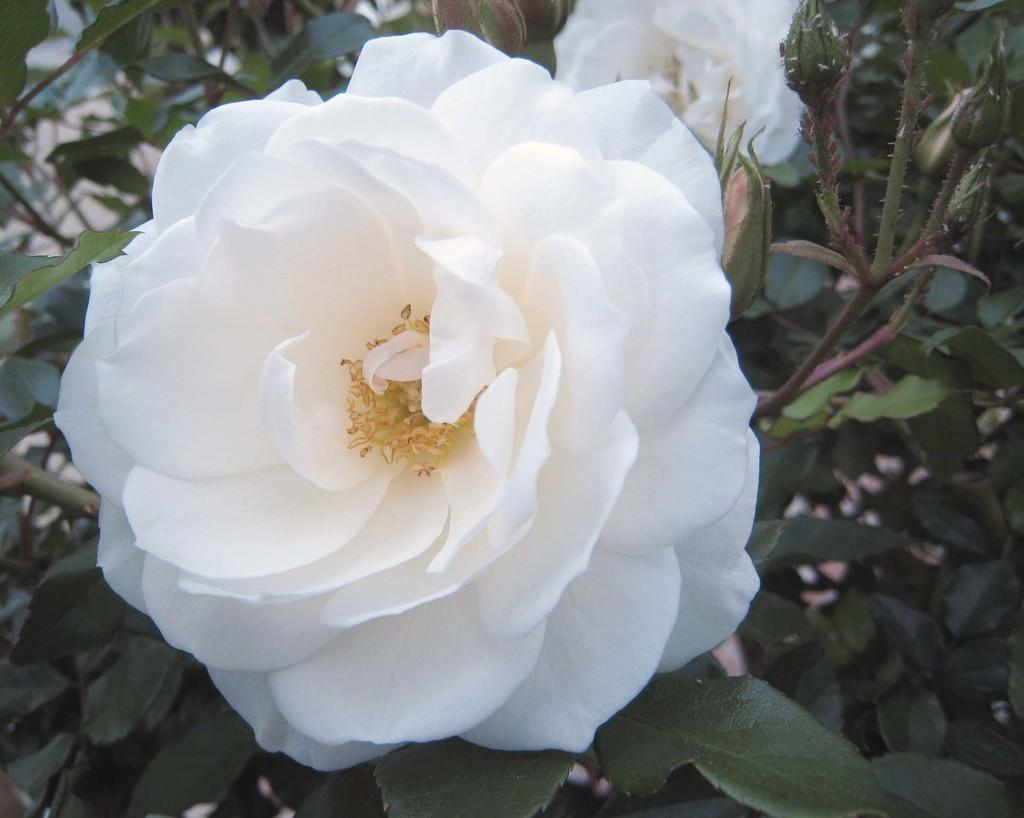What type of vegetation is in the front of the image? There are flowers in the front of the image. What can be seen in the background of the image? There are plants in the background of the image. What type of bread is being sold in the image? There is no bread present in the image; it features flowers in the front and plants in the background. What is the profit margin for the channel in the image? There is no mention of a channel or profit margin in the image, as it focuses on vegetation. 